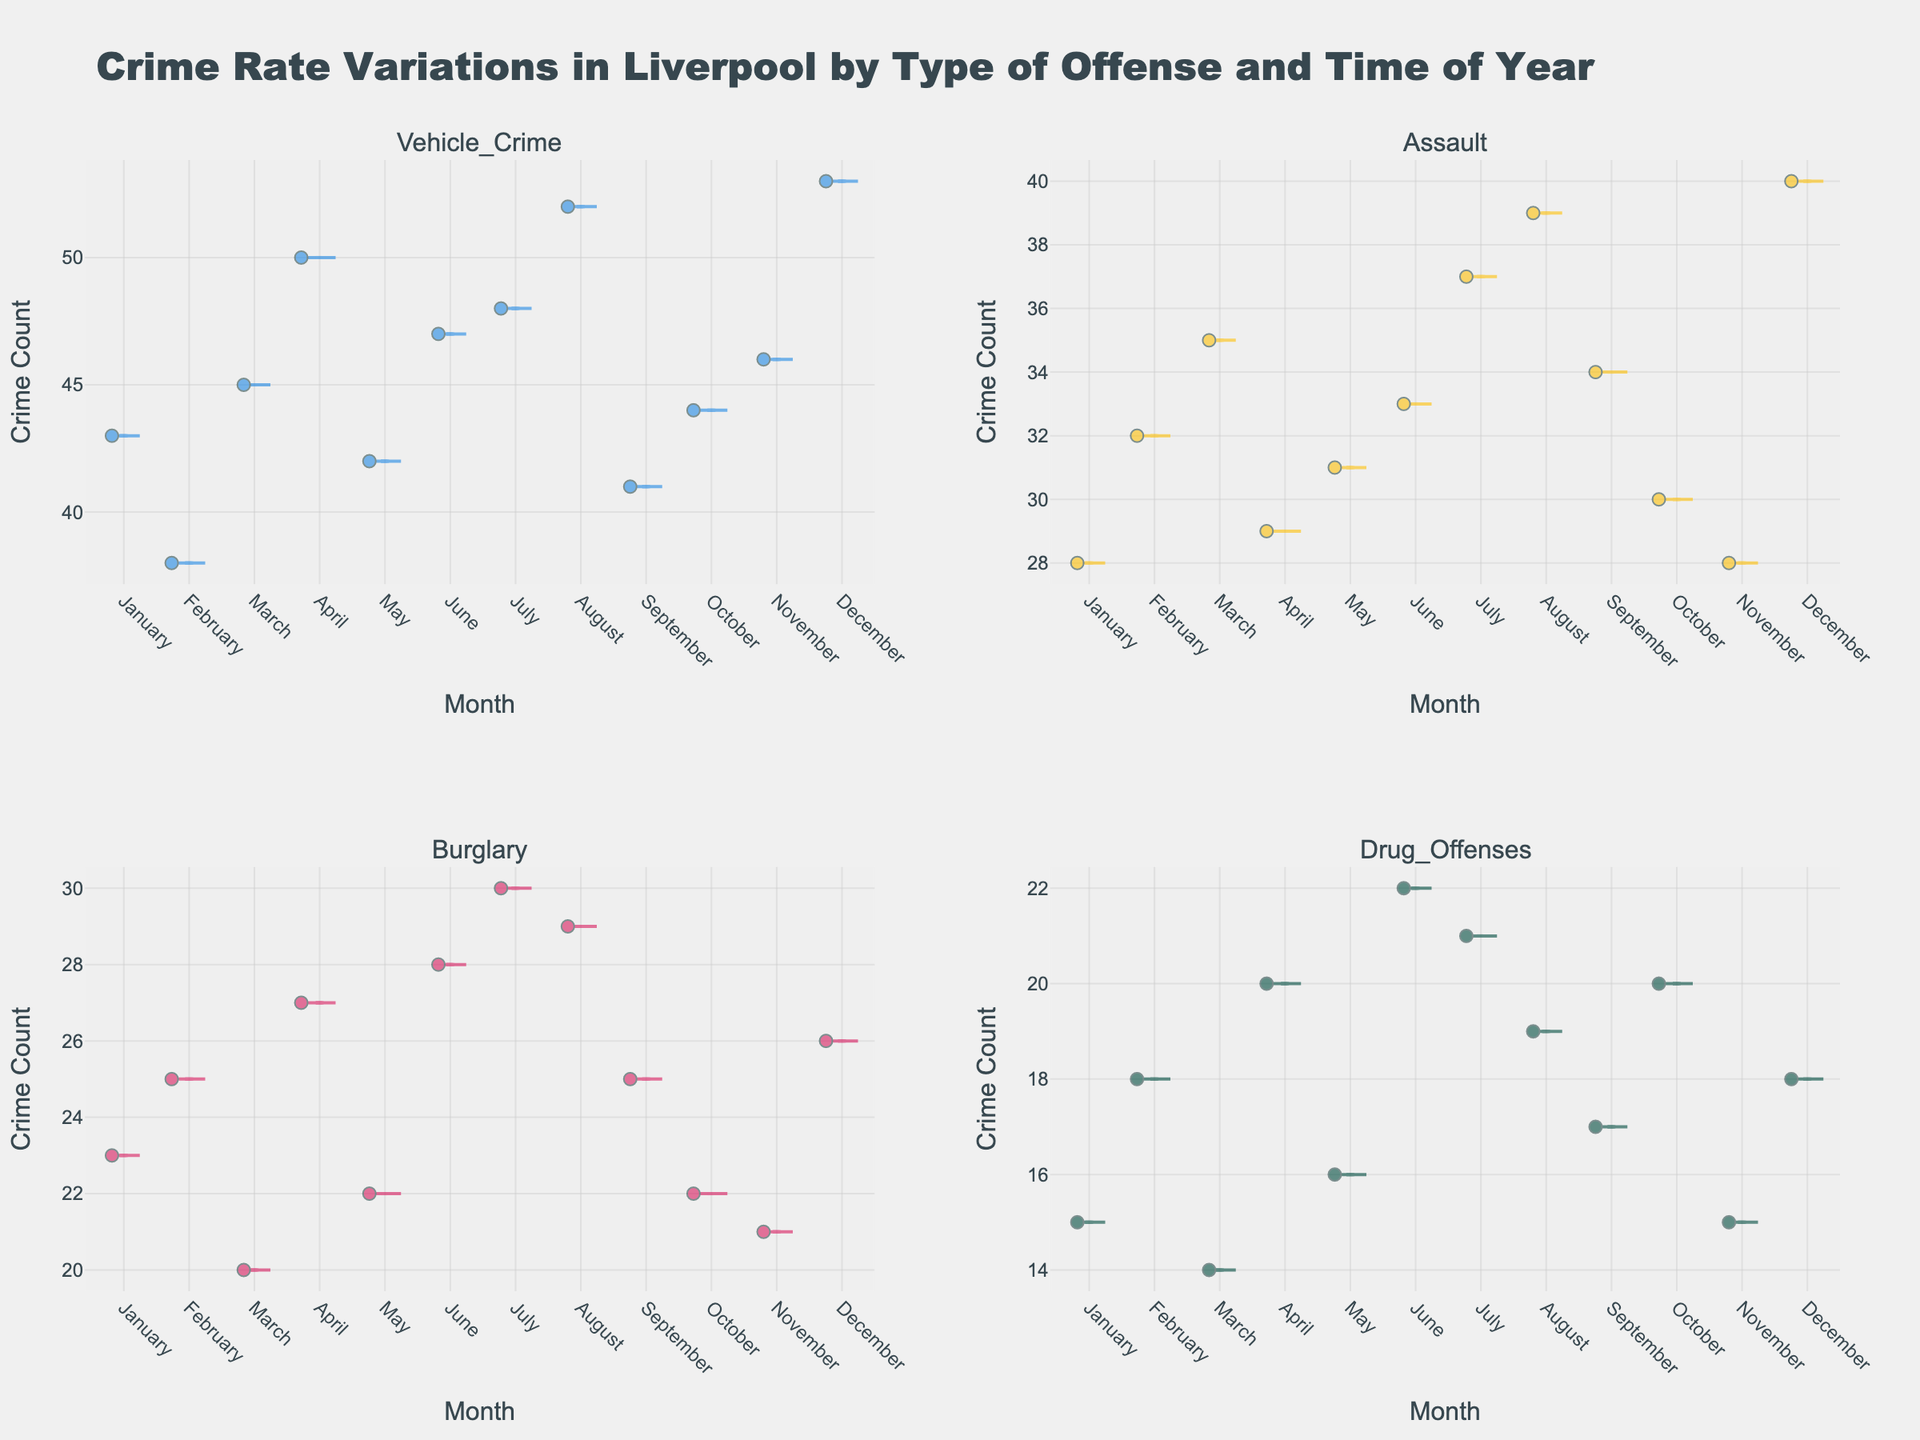What is the title of the figure? The title of the figure is displayed at the top. It reads "Crime Rate Variations in Liverpool by Type of Offense and Time of Year".
Answer: Crime Rate Variations in Liverpool by Type of Offense and Time of Year What are the four types of offenses shown in the figure? The subplot titles indicate the four types of offenses as Vehicle Crime, Assault, Burglary, and Drug Offenses.
Answer: Vehicle Crime, Assault, Burglary, Drug Offenses Which month has the highest crime count for Vehicle Crime? In the Vehicle Crime subplot, the violin plot shows the highest point at December, representing the highest crime count.
Answer: December What is the average crime count in March for all offense types? The crime counts for March in each subplot are: Vehicle Crime (45), Assault (35), Burglary (20), Drug Offenses (14). Summing these gives: 45 + 35 + 20 + 14 = 114. The average is 114 / 4 = 28.5.
Answer: 28.5 Which offense type has the most consistent crime count across the year? To find the most consistent crime count, we look for the offense with the smallest spread in its violin plot. Drug Offenses appear to have the least variation.
Answer: Drug Offenses How does the trend of crime counts in July compare between Burglary and Assault? In July, the Burglary plot shows a crime count of 30, while the Assault plot shows a crime count of 37. July has higher crime counts in Assault compared to Burglary.
Answer: Assault has higher counts than Burglary in July What is the mean crime count for Drug Offenses in the second half of the year (July to December)? The counts for Drug Offenses from July to December are: 21, 19, 17, 20, 15, 18. Summing gives: 21 + 19 + 17 + 20 + 15 + 18 = 110. The mean is 110 / 6 = 18.3.
Answer: 18.3 Which offense type shows a peak in crime counts during the summer months? Observing the subplots, Vehicle Crime shows a peak around the summer months (July and August).
Answer: Vehicle Crime Between Assault and Burglary, which has the lower crime count in November? In November, the subplot for Assault shows 28, and the subplot for Burglary shows 21. Burglary has a lower crime count in November.
Answer: Burglary 